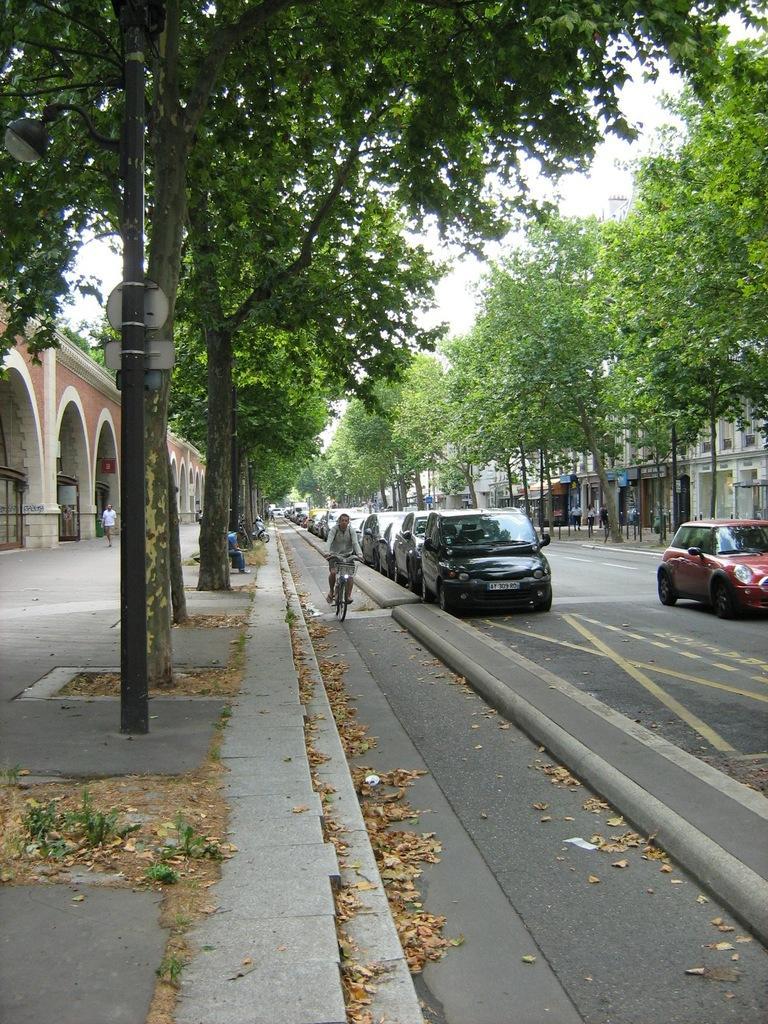Could you give a brief overview of what you see in this image? This image is taken outdoors. At the bottom of the image there is a road and a sidewalk. On the left side of the image there is a building with a few walls and doors and there are a few trees on the sidewalk. In the middle of the image a few cars are parked on the road and a man is riding on the bicycle. On the right side of the image there are a few buildings with walls, windows and doors and there are a few trees on the road. 